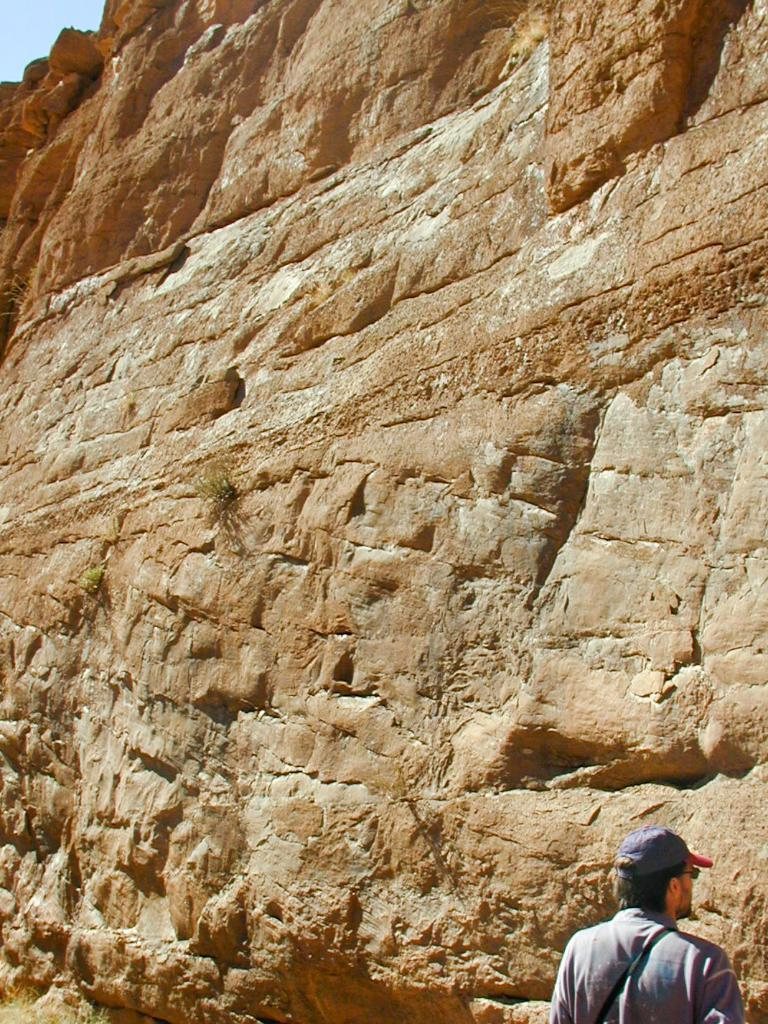Who is present in the image? There is a man in the image. What can be seen in the background of the image? There is a mountain and the sky visible in the background of the image. How many hands are visible in the image? There is no mention of hands in the image, so it is not possible to determine how many hands are visible. 